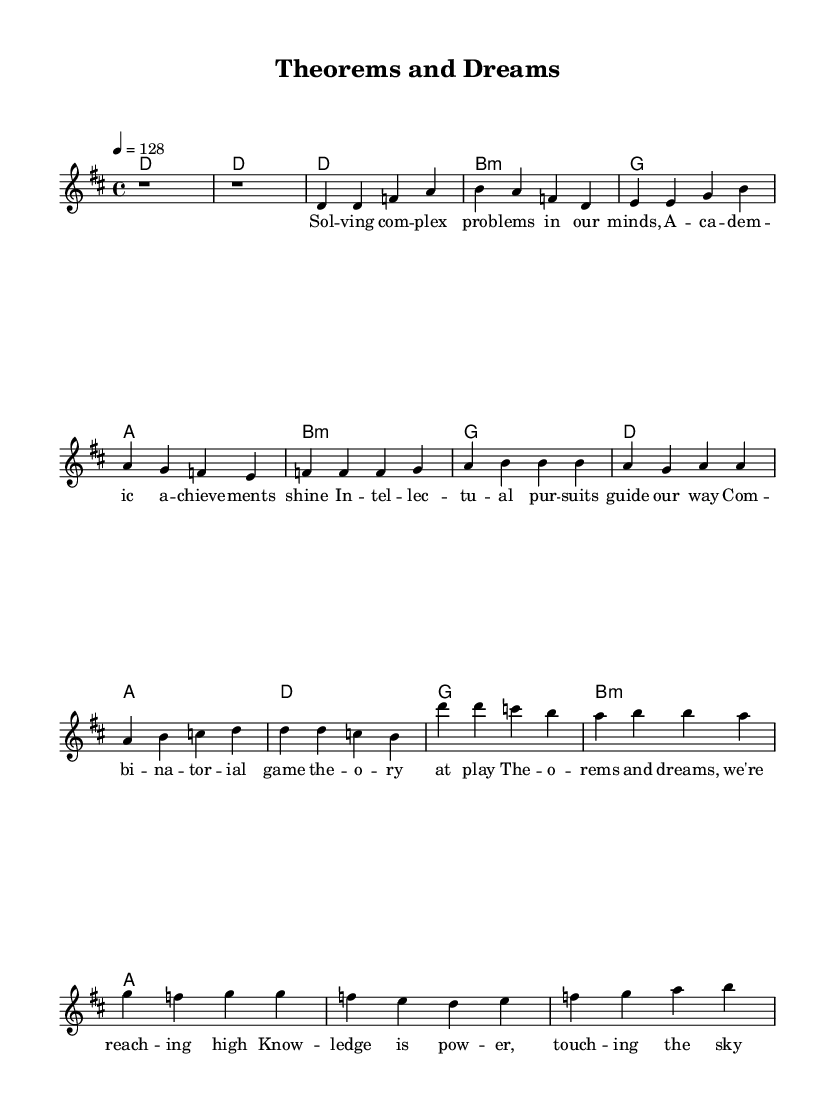What is the key signature of this music? The key signature is indicated in the global section of the code. It specifies D major, which has two sharps (F# and C#).
Answer: D major What is the time signature of this music? The time signature is also specified in the global section. It is shown as 4/4, meaning there are four beats per measure and a quarter note receives one beat.
Answer: 4/4 What is the tempo of this music? The tempo is set to 128 beats per minute, indicated in the global section of the code. This gives the song a lively and energetic feel, typical of K-Pop anthems.
Answer: 128 How many measures are in the chorus section? The chorus consists of four measures based on the defined melody. By counting the distinct sections, we can confirm that there are indeed four separate measures.
Answer: 4 What is the main theme celebrated in these lyrics? The lyrics reflect academic achievements and intellectual pursuits, focusing on themes of problem-solving and combinatorial game theory, which aligns with the K-Pop celebration of education and success.
Answer: Academic achievements What chord follows the melody during the first line of the pre-chorus? The first line of the pre-chorus has harmonies indicated in the code. The first chord of this section is B minor, which accompanies the melody.
Answer: B minor How does the energy of this K-Pop anthem reflect its subject matter? The high-energy tempo of 128 BPM combined with uplifting lyrics about intellectual pursuits creates a motivational atmosphere, characteristic of K-Pop anthems aimed at celebrating success and perseverance in academia.
Answer: Energetic celebration 